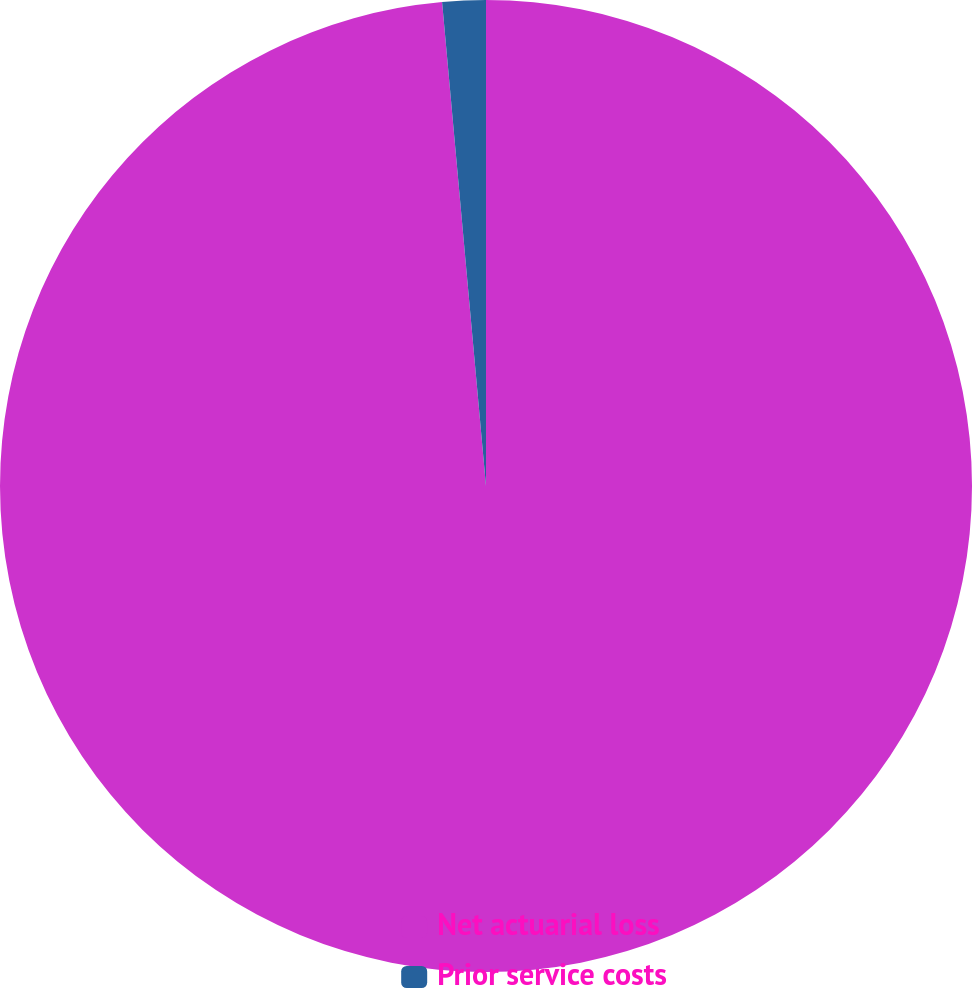Convert chart to OTSL. <chart><loc_0><loc_0><loc_500><loc_500><pie_chart><fcel>Net actuarial loss<fcel>Prior service costs<nl><fcel>98.56%<fcel>1.44%<nl></chart> 